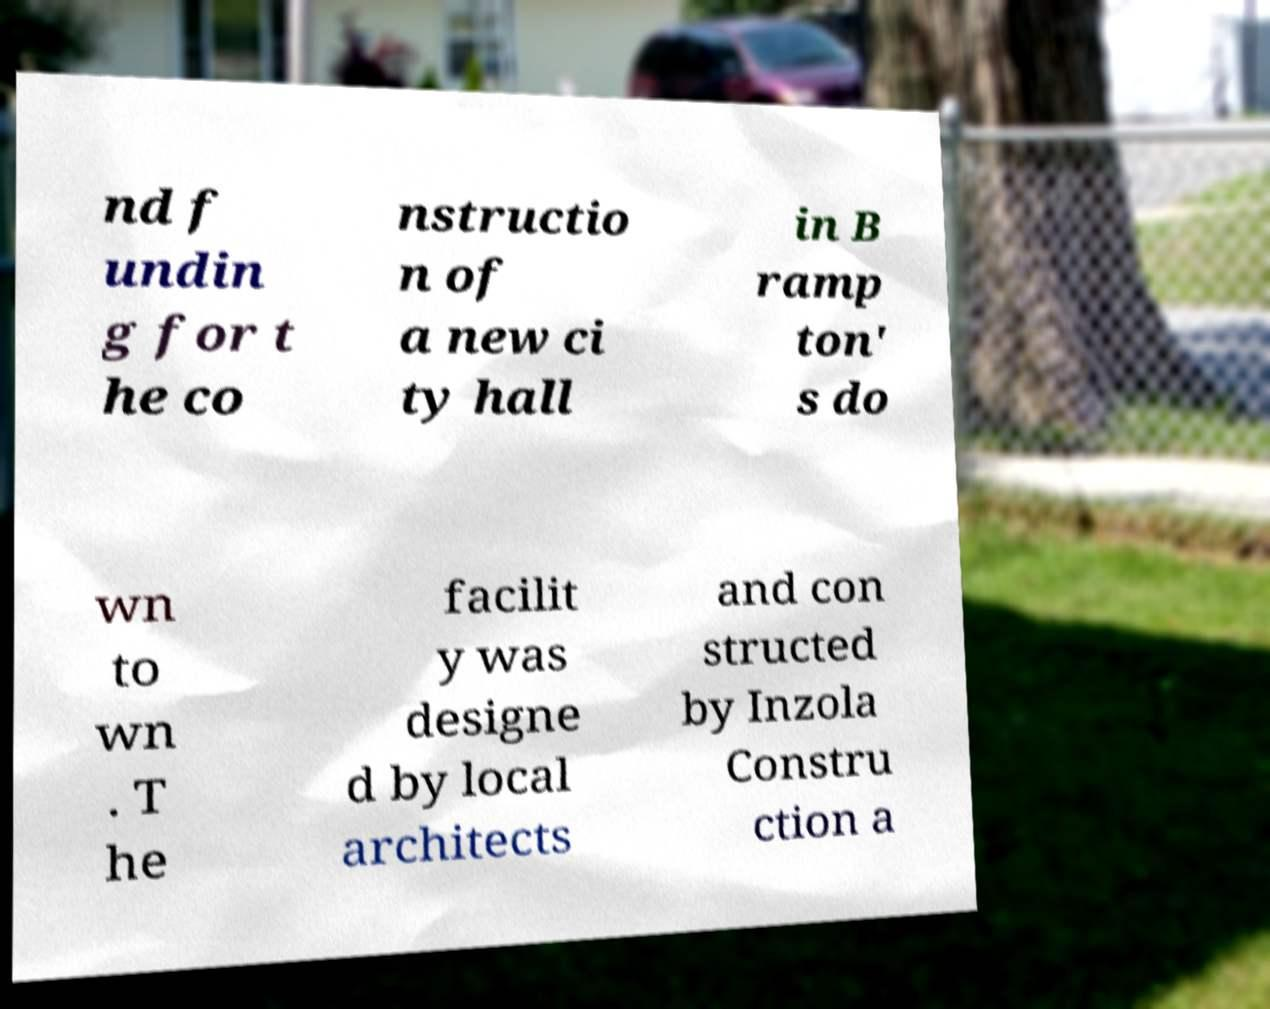Can you read and provide the text displayed in the image?This photo seems to have some interesting text. Can you extract and type it out for me? nd f undin g for t he co nstructio n of a new ci ty hall in B ramp ton' s do wn to wn . T he facilit y was designe d by local architects and con structed by Inzola Constru ction a 